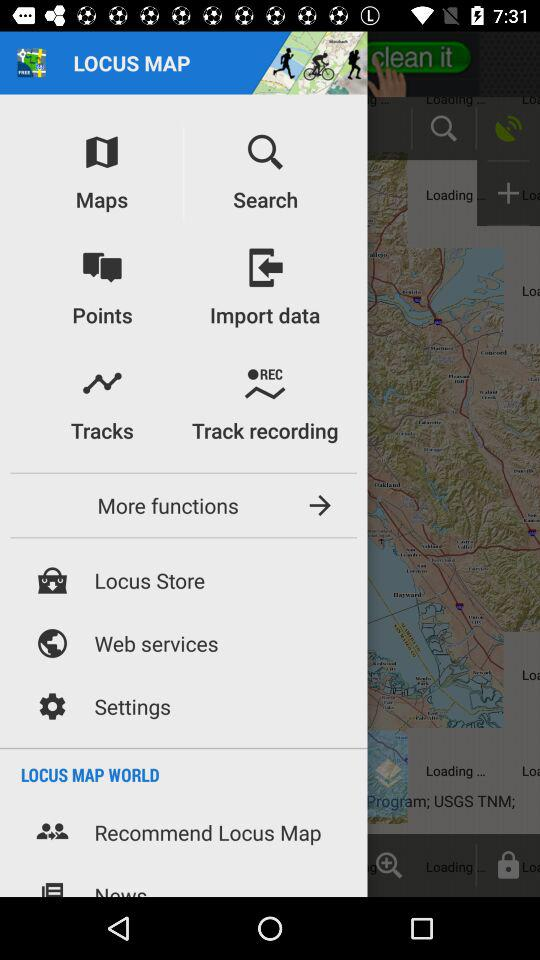What is the name of the application? The name of the application is "LOCUS MAP". 